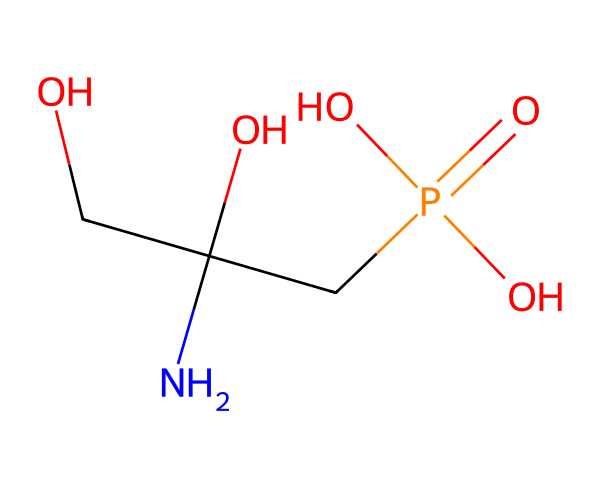What is the main functional group present in glyphosate? The chemical structure contains a carboxylic acid group (–COOH), which indicates that the main functional group is a carboxylic acid.
Answer: carboxylic acid How many oxygen atoms are in glyphosate? By examining the structure, we can count three oxygen atoms: one in the alcohol group, one in the phosphonic acid group, and one in the carboxylic acid group.
Answer: three What is the total number of carbon atoms in glyphosate? In the provided SMILES representation, there are three carbon atoms, one in the alcohol group and two in the central framework of the molecule.
Answer: three Which part of the glyphosate structure is responsible for its herbicidal activity? The presence of the phosphonic acid moiety contributes to glyphosate's ability to inhibit the shikimic acid pathway in plants, which is crucial for herbicidal activity.
Answer: phosphonic acid What type of herbicide is glyphosate classified as? Glyphosate is classified as a broad-spectrum herbicide due to its effectiveness against a wide range of weeds and grasses.
Answer: broad-spectrum Explain the overall charge of glyphosate at physiological pH. At physiological pH, glyphosate exists mainly in its deprotonated form (anionic) due to the ionization of its carboxylic and phosphonic acids, leading to an overall negative charge.
Answer: negative How does the chemical structure of glyphosate affect its solubility in water? The presence of polar functional groups, such as the carboxylic acid and phosphonic acid, increases glyphosate's polarity, enhancing its solubility in water.
Answer: polar 